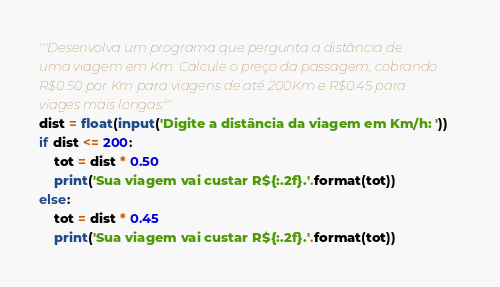Convert code to text. <code><loc_0><loc_0><loc_500><loc_500><_Python_>'''Desenvolva um programa que pergunta a distância de
uma viagem em Km. Calcule o preço da passagem, cobrando
R$0.50 por Km para viagens de até 200Km e R$0.45 para
viages mais longas.'''
dist = float(input('Digite a distância da viagem em Km/h: '))
if dist <= 200:
    tot = dist * 0.50
    print('Sua viagem vai custar R${:.2f}.'.format(tot))
else:
    tot = dist * 0.45
    print('Sua viagem vai custar R${:.2f}.'.format(tot))</code> 